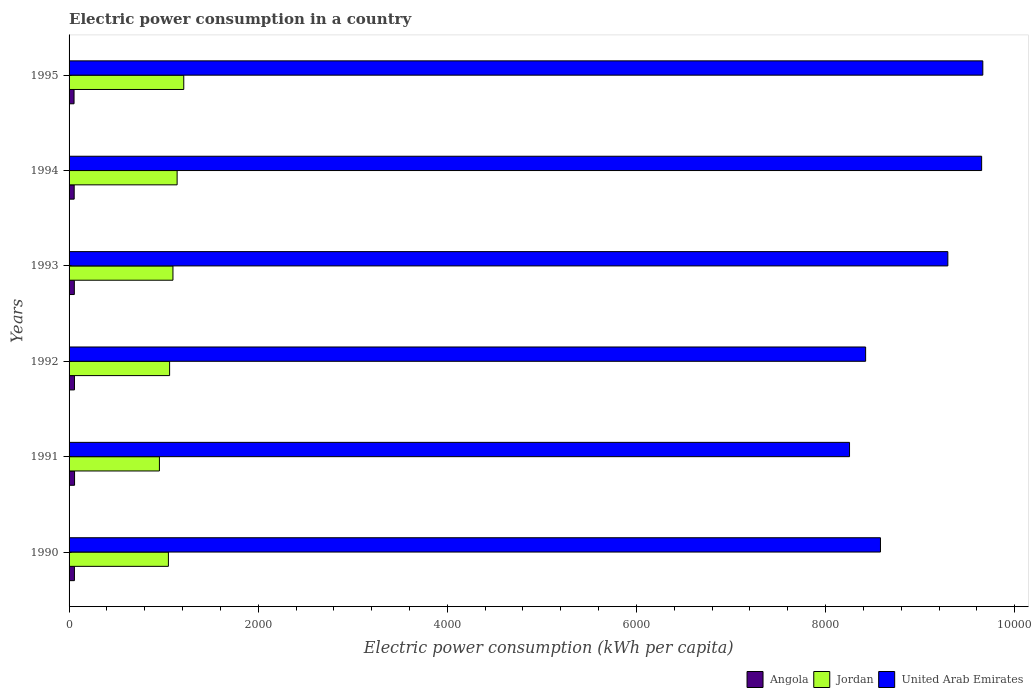How many groups of bars are there?
Provide a short and direct response. 6. Are the number of bars per tick equal to the number of legend labels?
Ensure brevity in your answer.  Yes. What is the label of the 3rd group of bars from the top?
Your answer should be compact. 1993. What is the electric power consumption in in Jordan in 1990?
Keep it short and to the point. 1050.47. Across all years, what is the maximum electric power consumption in in Angola?
Ensure brevity in your answer.  58.14. Across all years, what is the minimum electric power consumption in in Angola?
Your response must be concise. 52.67. In which year was the electric power consumption in in United Arab Emirates minimum?
Your response must be concise. 1991. What is the total electric power consumption in in Angola in the graph?
Offer a terse response. 334.17. What is the difference between the electric power consumption in in Angola in 1993 and that in 1995?
Your answer should be compact. 2.85. What is the difference between the electric power consumption in in United Arab Emirates in 1993 and the electric power consumption in in Jordan in 1991?
Provide a succinct answer. 8337.46. What is the average electric power consumption in in United Arab Emirates per year?
Your answer should be compact. 8977.13. In the year 1990, what is the difference between the electric power consumption in in United Arab Emirates and electric power consumption in in Angola?
Keep it short and to the point. 8523.77. What is the ratio of the electric power consumption in in United Arab Emirates in 1993 to that in 1995?
Give a very brief answer. 0.96. Is the electric power consumption in in Angola in 1993 less than that in 1995?
Ensure brevity in your answer.  No. Is the difference between the electric power consumption in in United Arab Emirates in 1991 and 1993 greater than the difference between the electric power consumption in in Angola in 1991 and 1993?
Make the answer very short. No. What is the difference between the highest and the second highest electric power consumption in in Angola?
Offer a very short reply. 1. What is the difference between the highest and the lowest electric power consumption in in Jordan?
Offer a very short reply. 257.44. In how many years, is the electric power consumption in in United Arab Emirates greater than the average electric power consumption in in United Arab Emirates taken over all years?
Give a very brief answer. 3. Is the sum of the electric power consumption in in Angola in 1991 and 1992 greater than the maximum electric power consumption in in Jordan across all years?
Your response must be concise. No. What does the 1st bar from the top in 1993 represents?
Ensure brevity in your answer.  United Arab Emirates. What does the 1st bar from the bottom in 1992 represents?
Ensure brevity in your answer.  Angola. What is the difference between two consecutive major ticks on the X-axis?
Your answer should be compact. 2000. Does the graph contain any zero values?
Give a very brief answer. No. Does the graph contain grids?
Your answer should be very brief. No. How many legend labels are there?
Give a very brief answer. 3. What is the title of the graph?
Provide a short and direct response. Electric power consumption in a country. Does "France" appear as one of the legend labels in the graph?
Give a very brief answer. No. What is the label or title of the X-axis?
Provide a succinct answer. Electric power consumption (kWh per capita). What is the Electric power consumption (kWh per capita) in Angola in 1990?
Your response must be concise. 56.61. What is the Electric power consumption (kWh per capita) in Jordan in 1990?
Offer a terse response. 1050.47. What is the Electric power consumption (kWh per capita) in United Arab Emirates in 1990?
Your answer should be compact. 8580.38. What is the Electric power consumption (kWh per capita) of Angola in 1991?
Keep it short and to the point. 58.14. What is the Electric power consumption (kWh per capita) in Jordan in 1991?
Your response must be concise. 955.43. What is the Electric power consumption (kWh per capita) in United Arab Emirates in 1991?
Make the answer very short. 8253.23. What is the Electric power consumption (kWh per capita) in Angola in 1992?
Provide a short and direct response. 57.14. What is the Electric power consumption (kWh per capita) of Jordan in 1992?
Provide a short and direct response. 1063.22. What is the Electric power consumption (kWh per capita) of United Arab Emirates in 1992?
Ensure brevity in your answer.  8423.42. What is the Electric power consumption (kWh per capita) in Angola in 1993?
Make the answer very short. 55.52. What is the Electric power consumption (kWh per capita) of Jordan in 1993?
Your response must be concise. 1098.57. What is the Electric power consumption (kWh per capita) in United Arab Emirates in 1993?
Keep it short and to the point. 9292.89. What is the Electric power consumption (kWh per capita) of Angola in 1994?
Your answer should be very brief. 54.08. What is the Electric power consumption (kWh per capita) of Jordan in 1994?
Your answer should be very brief. 1142.58. What is the Electric power consumption (kWh per capita) of United Arab Emirates in 1994?
Provide a short and direct response. 9650.26. What is the Electric power consumption (kWh per capita) of Angola in 1995?
Your answer should be very brief. 52.67. What is the Electric power consumption (kWh per capita) of Jordan in 1995?
Provide a short and direct response. 1212.87. What is the Electric power consumption (kWh per capita) in United Arab Emirates in 1995?
Keep it short and to the point. 9662.61. Across all years, what is the maximum Electric power consumption (kWh per capita) in Angola?
Your answer should be compact. 58.14. Across all years, what is the maximum Electric power consumption (kWh per capita) of Jordan?
Offer a terse response. 1212.87. Across all years, what is the maximum Electric power consumption (kWh per capita) of United Arab Emirates?
Make the answer very short. 9662.61. Across all years, what is the minimum Electric power consumption (kWh per capita) in Angola?
Provide a short and direct response. 52.67. Across all years, what is the minimum Electric power consumption (kWh per capita) in Jordan?
Provide a succinct answer. 955.43. Across all years, what is the minimum Electric power consumption (kWh per capita) in United Arab Emirates?
Make the answer very short. 8253.23. What is the total Electric power consumption (kWh per capita) of Angola in the graph?
Give a very brief answer. 334.17. What is the total Electric power consumption (kWh per capita) in Jordan in the graph?
Your response must be concise. 6523.14. What is the total Electric power consumption (kWh per capita) in United Arab Emirates in the graph?
Ensure brevity in your answer.  5.39e+04. What is the difference between the Electric power consumption (kWh per capita) in Angola in 1990 and that in 1991?
Keep it short and to the point. -1.53. What is the difference between the Electric power consumption (kWh per capita) of Jordan in 1990 and that in 1991?
Provide a short and direct response. 95.04. What is the difference between the Electric power consumption (kWh per capita) of United Arab Emirates in 1990 and that in 1991?
Offer a terse response. 327.15. What is the difference between the Electric power consumption (kWh per capita) in Angola in 1990 and that in 1992?
Your answer should be compact. -0.52. What is the difference between the Electric power consumption (kWh per capita) of Jordan in 1990 and that in 1992?
Provide a succinct answer. -12.75. What is the difference between the Electric power consumption (kWh per capita) in United Arab Emirates in 1990 and that in 1992?
Offer a terse response. 156.96. What is the difference between the Electric power consumption (kWh per capita) in Angola in 1990 and that in 1993?
Provide a short and direct response. 1.09. What is the difference between the Electric power consumption (kWh per capita) in Jordan in 1990 and that in 1993?
Provide a succinct answer. -48.09. What is the difference between the Electric power consumption (kWh per capita) of United Arab Emirates in 1990 and that in 1993?
Offer a very short reply. -712.51. What is the difference between the Electric power consumption (kWh per capita) of Angola in 1990 and that in 1994?
Provide a succinct answer. 2.54. What is the difference between the Electric power consumption (kWh per capita) of Jordan in 1990 and that in 1994?
Your answer should be very brief. -92.1. What is the difference between the Electric power consumption (kWh per capita) of United Arab Emirates in 1990 and that in 1994?
Your answer should be very brief. -1069.88. What is the difference between the Electric power consumption (kWh per capita) of Angola in 1990 and that in 1995?
Provide a short and direct response. 3.94. What is the difference between the Electric power consumption (kWh per capita) of Jordan in 1990 and that in 1995?
Ensure brevity in your answer.  -162.4. What is the difference between the Electric power consumption (kWh per capita) in United Arab Emirates in 1990 and that in 1995?
Your answer should be compact. -1082.23. What is the difference between the Electric power consumption (kWh per capita) in Angola in 1991 and that in 1992?
Make the answer very short. 1. What is the difference between the Electric power consumption (kWh per capita) of Jordan in 1991 and that in 1992?
Your answer should be very brief. -107.79. What is the difference between the Electric power consumption (kWh per capita) in United Arab Emirates in 1991 and that in 1992?
Your response must be concise. -170.19. What is the difference between the Electric power consumption (kWh per capita) in Angola in 1991 and that in 1993?
Provide a succinct answer. 2.62. What is the difference between the Electric power consumption (kWh per capita) in Jordan in 1991 and that in 1993?
Provide a short and direct response. -143.14. What is the difference between the Electric power consumption (kWh per capita) in United Arab Emirates in 1991 and that in 1993?
Your answer should be compact. -1039.66. What is the difference between the Electric power consumption (kWh per capita) in Angola in 1991 and that in 1994?
Provide a succinct answer. 4.06. What is the difference between the Electric power consumption (kWh per capita) in Jordan in 1991 and that in 1994?
Make the answer very short. -187.15. What is the difference between the Electric power consumption (kWh per capita) in United Arab Emirates in 1991 and that in 1994?
Make the answer very short. -1397.03. What is the difference between the Electric power consumption (kWh per capita) of Angola in 1991 and that in 1995?
Your answer should be very brief. 5.47. What is the difference between the Electric power consumption (kWh per capita) in Jordan in 1991 and that in 1995?
Offer a very short reply. -257.44. What is the difference between the Electric power consumption (kWh per capita) of United Arab Emirates in 1991 and that in 1995?
Offer a very short reply. -1409.38. What is the difference between the Electric power consumption (kWh per capita) of Angola in 1992 and that in 1993?
Offer a very short reply. 1.61. What is the difference between the Electric power consumption (kWh per capita) of Jordan in 1992 and that in 1993?
Your answer should be compact. -35.35. What is the difference between the Electric power consumption (kWh per capita) of United Arab Emirates in 1992 and that in 1993?
Your answer should be compact. -869.47. What is the difference between the Electric power consumption (kWh per capita) of Angola in 1992 and that in 1994?
Your answer should be very brief. 3.06. What is the difference between the Electric power consumption (kWh per capita) in Jordan in 1992 and that in 1994?
Offer a very short reply. -79.36. What is the difference between the Electric power consumption (kWh per capita) of United Arab Emirates in 1992 and that in 1994?
Offer a terse response. -1226.84. What is the difference between the Electric power consumption (kWh per capita) of Angola in 1992 and that in 1995?
Offer a terse response. 4.46. What is the difference between the Electric power consumption (kWh per capita) in Jordan in 1992 and that in 1995?
Offer a very short reply. -149.65. What is the difference between the Electric power consumption (kWh per capita) of United Arab Emirates in 1992 and that in 1995?
Your response must be concise. -1239.2. What is the difference between the Electric power consumption (kWh per capita) in Angola in 1993 and that in 1994?
Your answer should be very brief. 1.45. What is the difference between the Electric power consumption (kWh per capita) of Jordan in 1993 and that in 1994?
Make the answer very short. -44.01. What is the difference between the Electric power consumption (kWh per capita) in United Arab Emirates in 1993 and that in 1994?
Provide a succinct answer. -357.37. What is the difference between the Electric power consumption (kWh per capita) in Angola in 1993 and that in 1995?
Your response must be concise. 2.85. What is the difference between the Electric power consumption (kWh per capita) of Jordan in 1993 and that in 1995?
Your answer should be very brief. -114.31. What is the difference between the Electric power consumption (kWh per capita) in United Arab Emirates in 1993 and that in 1995?
Give a very brief answer. -369.72. What is the difference between the Electric power consumption (kWh per capita) of Angola in 1994 and that in 1995?
Keep it short and to the point. 1.4. What is the difference between the Electric power consumption (kWh per capita) in Jordan in 1994 and that in 1995?
Keep it short and to the point. -70.3. What is the difference between the Electric power consumption (kWh per capita) in United Arab Emirates in 1994 and that in 1995?
Provide a short and direct response. -12.35. What is the difference between the Electric power consumption (kWh per capita) in Angola in 1990 and the Electric power consumption (kWh per capita) in Jordan in 1991?
Provide a succinct answer. -898.82. What is the difference between the Electric power consumption (kWh per capita) in Angola in 1990 and the Electric power consumption (kWh per capita) in United Arab Emirates in 1991?
Provide a short and direct response. -8196.62. What is the difference between the Electric power consumption (kWh per capita) in Jordan in 1990 and the Electric power consumption (kWh per capita) in United Arab Emirates in 1991?
Your answer should be compact. -7202.76. What is the difference between the Electric power consumption (kWh per capita) in Angola in 1990 and the Electric power consumption (kWh per capita) in Jordan in 1992?
Provide a succinct answer. -1006.61. What is the difference between the Electric power consumption (kWh per capita) of Angola in 1990 and the Electric power consumption (kWh per capita) of United Arab Emirates in 1992?
Offer a terse response. -8366.8. What is the difference between the Electric power consumption (kWh per capita) in Jordan in 1990 and the Electric power consumption (kWh per capita) in United Arab Emirates in 1992?
Keep it short and to the point. -7372.95. What is the difference between the Electric power consumption (kWh per capita) of Angola in 1990 and the Electric power consumption (kWh per capita) of Jordan in 1993?
Your answer should be compact. -1041.95. What is the difference between the Electric power consumption (kWh per capita) of Angola in 1990 and the Electric power consumption (kWh per capita) of United Arab Emirates in 1993?
Make the answer very short. -9236.28. What is the difference between the Electric power consumption (kWh per capita) of Jordan in 1990 and the Electric power consumption (kWh per capita) of United Arab Emirates in 1993?
Keep it short and to the point. -8242.42. What is the difference between the Electric power consumption (kWh per capita) of Angola in 1990 and the Electric power consumption (kWh per capita) of Jordan in 1994?
Offer a very short reply. -1085.96. What is the difference between the Electric power consumption (kWh per capita) of Angola in 1990 and the Electric power consumption (kWh per capita) of United Arab Emirates in 1994?
Your answer should be very brief. -9593.65. What is the difference between the Electric power consumption (kWh per capita) in Jordan in 1990 and the Electric power consumption (kWh per capita) in United Arab Emirates in 1994?
Ensure brevity in your answer.  -8599.79. What is the difference between the Electric power consumption (kWh per capita) of Angola in 1990 and the Electric power consumption (kWh per capita) of Jordan in 1995?
Offer a very short reply. -1156.26. What is the difference between the Electric power consumption (kWh per capita) in Angola in 1990 and the Electric power consumption (kWh per capita) in United Arab Emirates in 1995?
Give a very brief answer. -9606. What is the difference between the Electric power consumption (kWh per capita) of Jordan in 1990 and the Electric power consumption (kWh per capita) of United Arab Emirates in 1995?
Provide a short and direct response. -8612.14. What is the difference between the Electric power consumption (kWh per capita) of Angola in 1991 and the Electric power consumption (kWh per capita) of Jordan in 1992?
Provide a short and direct response. -1005.08. What is the difference between the Electric power consumption (kWh per capita) in Angola in 1991 and the Electric power consumption (kWh per capita) in United Arab Emirates in 1992?
Offer a very short reply. -8365.28. What is the difference between the Electric power consumption (kWh per capita) of Jordan in 1991 and the Electric power consumption (kWh per capita) of United Arab Emirates in 1992?
Provide a short and direct response. -7467.99. What is the difference between the Electric power consumption (kWh per capita) of Angola in 1991 and the Electric power consumption (kWh per capita) of Jordan in 1993?
Your response must be concise. -1040.43. What is the difference between the Electric power consumption (kWh per capita) of Angola in 1991 and the Electric power consumption (kWh per capita) of United Arab Emirates in 1993?
Keep it short and to the point. -9234.75. What is the difference between the Electric power consumption (kWh per capita) of Jordan in 1991 and the Electric power consumption (kWh per capita) of United Arab Emirates in 1993?
Keep it short and to the point. -8337.46. What is the difference between the Electric power consumption (kWh per capita) of Angola in 1991 and the Electric power consumption (kWh per capita) of Jordan in 1994?
Make the answer very short. -1084.43. What is the difference between the Electric power consumption (kWh per capita) in Angola in 1991 and the Electric power consumption (kWh per capita) in United Arab Emirates in 1994?
Your answer should be compact. -9592.12. What is the difference between the Electric power consumption (kWh per capita) of Jordan in 1991 and the Electric power consumption (kWh per capita) of United Arab Emirates in 1994?
Ensure brevity in your answer.  -8694.83. What is the difference between the Electric power consumption (kWh per capita) in Angola in 1991 and the Electric power consumption (kWh per capita) in Jordan in 1995?
Make the answer very short. -1154.73. What is the difference between the Electric power consumption (kWh per capita) of Angola in 1991 and the Electric power consumption (kWh per capita) of United Arab Emirates in 1995?
Your answer should be compact. -9604.47. What is the difference between the Electric power consumption (kWh per capita) of Jordan in 1991 and the Electric power consumption (kWh per capita) of United Arab Emirates in 1995?
Your response must be concise. -8707.18. What is the difference between the Electric power consumption (kWh per capita) of Angola in 1992 and the Electric power consumption (kWh per capita) of Jordan in 1993?
Your answer should be compact. -1041.43. What is the difference between the Electric power consumption (kWh per capita) in Angola in 1992 and the Electric power consumption (kWh per capita) in United Arab Emirates in 1993?
Provide a short and direct response. -9235.76. What is the difference between the Electric power consumption (kWh per capita) of Jordan in 1992 and the Electric power consumption (kWh per capita) of United Arab Emirates in 1993?
Ensure brevity in your answer.  -8229.67. What is the difference between the Electric power consumption (kWh per capita) of Angola in 1992 and the Electric power consumption (kWh per capita) of Jordan in 1994?
Offer a terse response. -1085.44. What is the difference between the Electric power consumption (kWh per capita) in Angola in 1992 and the Electric power consumption (kWh per capita) in United Arab Emirates in 1994?
Provide a succinct answer. -9593.13. What is the difference between the Electric power consumption (kWh per capita) of Jordan in 1992 and the Electric power consumption (kWh per capita) of United Arab Emirates in 1994?
Keep it short and to the point. -8587.04. What is the difference between the Electric power consumption (kWh per capita) in Angola in 1992 and the Electric power consumption (kWh per capita) in Jordan in 1995?
Your response must be concise. -1155.74. What is the difference between the Electric power consumption (kWh per capita) of Angola in 1992 and the Electric power consumption (kWh per capita) of United Arab Emirates in 1995?
Ensure brevity in your answer.  -9605.48. What is the difference between the Electric power consumption (kWh per capita) in Jordan in 1992 and the Electric power consumption (kWh per capita) in United Arab Emirates in 1995?
Provide a succinct answer. -8599.39. What is the difference between the Electric power consumption (kWh per capita) of Angola in 1993 and the Electric power consumption (kWh per capita) of Jordan in 1994?
Give a very brief answer. -1087.05. What is the difference between the Electric power consumption (kWh per capita) in Angola in 1993 and the Electric power consumption (kWh per capita) in United Arab Emirates in 1994?
Offer a very short reply. -9594.74. What is the difference between the Electric power consumption (kWh per capita) in Jordan in 1993 and the Electric power consumption (kWh per capita) in United Arab Emirates in 1994?
Offer a very short reply. -8551.7. What is the difference between the Electric power consumption (kWh per capita) of Angola in 1993 and the Electric power consumption (kWh per capita) of Jordan in 1995?
Offer a very short reply. -1157.35. What is the difference between the Electric power consumption (kWh per capita) of Angola in 1993 and the Electric power consumption (kWh per capita) of United Arab Emirates in 1995?
Keep it short and to the point. -9607.09. What is the difference between the Electric power consumption (kWh per capita) in Jordan in 1993 and the Electric power consumption (kWh per capita) in United Arab Emirates in 1995?
Keep it short and to the point. -8564.05. What is the difference between the Electric power consumption (kWh per capita) in Angola in 1994 and the Electric power consumption (kWh per capita) in Jordan in 1995?
Give a very brief answer. -1158.79. What is the difference between the Electric power consumption (kWh per capita) in Angola in 1994 and the Electric power consumption (kWh per capita) in United Arab Emirates in 1995?
Provide a succinct answer. -9608.54. What is the difference between the Electric power consumption (kWh per capita) in Jordan in 1994 and the Electric power consumption (kWh per capita) in United Arab Emirates in 1995?
Your response must be concise. -8520.04. What is the average Electric power consumption (kWh per capita) of Angola per year?
Your response must be concise. 55.69. What is the average Electric power consumption (kWh per capita) in Jordan per year?
Give a very brief answer. 1087.19. What is the average Electric power consumption (kWh per capita) in United Arab Emirates per year?
Ensure brevity in your answer.  8977.13. In the year 1990, what is the difference between the Electric power consumption (kWh per capita) of Angola and Electric power consumption (kWh per capita) of Jordan?
Your response must be concise. -993.86. In the year 1990, what is the difference between the Electric power consumption (kWh per capita) of Angola and Electric power consumption (kWh per capita) of United Arab Emirates?
Offer a very short reply. -8523.77. In the year 1990, what is the difference between the Electric power consumption (kWh per capita) in Jordan and Electric power consumption (kWh per capita) in United Arab Emirates?
Your answer should be very brief. -7529.91. In the year 1991, what is the difference between the Electric power consumption (kWh per capita) of Angola and Electric power consumption (kWh per capita) of Jordan?
Give a very brief answer. -897.29. In the year 1991, what is the difference between the Electric power consumption (kWh per capita) in Angola and Electric power consumption (kWh per capita) in United Arab Emirates?
Ensure brevity in your answer.  -8195.09. In the year 1991, what is the difference between the Electric power consumption (kWh per capita) in Jordan and Electric power consumption (kWh per capita) in United Arab Emirates?
Make the answer very short. -7297.8. In the year 1992, what is the difference between the Electric power consumption (kWh per capita) in Angola and Electric power consumption (kWh per capita) in Jordan?
Offer a terse response. -1006.08. In the year 1992, what is the difference between the Electric power consumption (kWh per capita) of Angola and Electric power consumption (kWh per capita) of United Arab Emirates?
Provide a succinct answer. -8366.28. In the year 1992, what is the difference between the Electric power consumption (kWh per capita) in Jordan and Electric power consumption (kWh per capita) in United Arab Emirates?
Make the answer very short. -7360.2. In the year 1993, what is the difference between the Electric power consumption (kWh per capita) in Angola and Electric power consumption (kWh per capita) in Jordan?
Offer a terse response. -1043.04. In the year 1993, what is the difference between the Electric power consumption (kWh per capita) of Angola and Electric power consumption (kWh per capita) of United Arab Emirates?
Offer a very short reply. -9237.37. In the year 1993, what is the difference between the Electric power consumption (kWh per capita) of Jordan and Electric power consumption (kWh per capita) of United Arab Emirates?
Provide a succinct answer. -8194.33. In the year 1994, what is the difference between the Electric power consumption (kWh per capita) in Angola and Electric power consumption (kWh per capita) in Jordan?
Ensure brevity in your answer.  -1088.5. In the year 1994, what is the difference between the Electric power consumption (kWh per capita) of Angola and Electric power consumption (kWh per capita) of United Arab Emirates?
Give a very brief answer. -9596.19. In the year 1994, what is the difference between the Electric power consumption (kWh per capita) in Jordan and Electric power consumption (kWh per capita) in United Arab Emirates?
Keep it short and to the point. -8507.69. In the year 1995, what is the difference between the Electric power consumption (kWh per capita) of Angola and Electric power consumption (kWh per capita) of Jordan?
Ensure brevity in your answer.  -1160.2. In the year 1995, what is the difference between the Electric power consumption (kWh per capita) in Angola and Electric power consumption (kWh per capita) in United Arab Emirates?
Provide a succinct answer. -9609.94. In the year 1995, what is the difference between the Electric power consumption (kWh per capita) of Jordan and Electric power consumption (kWh per capita) of United Arab Emirates?
Give a very brief answer. -8449.74. What is the ratio of the Electric power consumption (kWh per capita) in Angola in 1990 to that in 1991?
Your answer should be compact. 0.97. What is the ratio of the Electric power consumption (kWh per capita) of Jordan in 1990 to that in 1991?
Offer a terse response. 1.1. What is the ratio of the Electric power consumption (kWh per capita) of United Arab Emirates in 1990 to that in 1991?
Provide a short and direct response. 1.04. What is the ratio of the Electric power consumption (kWh per capita) in Angola in 1990 to that in 1992?
Give a very brief answer. 0.99. What is the ratio of the Electric power consumption (kWh per capita) in Jordan in 1990 to that in 1992?
Your answer should be compact. 0.99. What is the ratio of the Electric power consumption (kWh per capita) of United Arab Emirates in 1990 to that in 1992?
Make the answer very short. 1.02. What is the ratio of the Electric power consumption (kWh per capita) in Angola in 1990 to that in 1993?
Give a very brief answer. 1.02. What is the ratio of the Electric power consumption (kWh per capita) in Jordan in 1990 to that in 1993?
Make the answer very short. 0.96. What is the ratio of the Electric power consumption (kWh per capita) of United Arab Emirates in 1990 to that in 1993?
Give a very brief answer. 0.92. What is the ratio of the Electric power consumption (kWh per capita) in Angola in 1990 to that in 1994?
Make the answer very short. 1.05. What is the ratio of the Electric power consumption (kWh per capita) of Jordan in 1990 to that in 1994?
Keep it short and to the point. 0.92. What is the ratio of the Electric power consumption (kWh per capita) of United Arab Emirates in 1990 to that in 1994?
Offer a very short reply. 0.89. What is the ratio of the Electric power consumption (kWh per capita) in Angola in 1990 to that in 1995?
Offer a very short reply. 1.07. What is the ratio of the Electric power consumption (kWh per capita) in Jordan in 1990 to that in 1995?
Your response must be concise. 0.87. What is the ratio of the Electric power consumption (kWh per capita) of United Arab Emirates in 1990 to that in 1995?
Provide a short and direct response. 0.89. What is the ratio of the Electric power consumption (kWh per capita) in Angola in 1991 to that in 1992?
Provide a short and direct response. 1.02. What is the ratio of the Electric power consumption (kWh per capita) in Jordan in 1991 to that in 1992?
Offer a terse response. 0.9. What is the ratio of the Electric power consumption (kWh per capita) in United Arab Emirates in 1991 to that in 1992?
Your response must be concise. 0.98. What is the ratio of the Electric power consumption (kWh per capita) of Angola in 1991 to that in 1993?
Provide a succinct answer. 1.05. What is the ratio of the Electric power consumption (kWh per capita) in Jordan in 1991 to that in 1993?
Offer a very short reply. 0.87. What is the ratio of the Electric power consumption (kWh per capita) of United Arab Emirates in 1991 to that in 1993?
Your response must be concise. 0.89. What is the ratio of the Electric power consumption (kWh per capita) in Angola in 1991 to that in 1994?
Provide a short and direct response. 1.08. What is the ratio of the Electric power consumption (kWh per capita) of Jordan in 1991 to that in 1994?
Give a very brief answer. 0.84. What is the ratio of the Electric power consumption (kWh per capita) in United Arab Emirates in 1991 to that in 1994?
Your response must be concise. 0.86. What is the ratio of the Electric power consumption (kWh per capita) of Angola in 1991 to that in 1995?
Make the answer very short. 1.1. What is the ratio of the Electric power consumption (kWh per capita) of Jordan in 1991 to that in 1995?
Your answer should be very brief. 0.79. What is the ratio of the Electric power consumption (kWh per capita) of United Arab Emirates in 1991 to that in 1995?
Provide a short and direct response. 0.85. What is the ratio of the Electric power consumption (kWh per capita) in Angola in 1992 to that in 1993?
Make the answer very short. 1.03. What is the ratio of the Electric power consumption (kWh per capita) of Jordan in 1992 to that in 1993?
Your answer should be compact. 0.97. What is the ratio of the Electric power consumption (kWh per capita) in United Arab Emirates in 1992 to that in 1993?
Make the answer very short. 0.91. What is the ratio of the Electric power consumption (kWh per capita) in Angola in 1992 to that in 1994?
Provide a short and direct response. 1.06. What is the ratio of the Electric power consumption (kWh per capita) of Jordan in 1992 to that in 1994?
Your response must be concise. 0.93. What is the ratio of the Electric power consumption (kWh per capita) in United Arab Emirates in 1992 to that in 1994?
Make the answer very short. 0.87. What is the ratio of the Electric power consumption (kWh per capita) of Angola in 1992 to that in 1995?
Offer a terse response. 1.08. What is the ratio of the Electric power consumption (kWh per capita) in Jordan in 1992 to that in 1995?
Offer a very short reply. 0.88. What is the ratio of the Electric power consumption (kWh per capita) in United Arab Emirates in 1992 to that in 1995?
Provide a short and direct response. 0.87. What is the ratio of the Electric power consumption (kWh per capita) of Angola in 1993 to that in 1994?
Provide a succinct answer. 1.03. What is the ratio of the Electric power consumption (kWh per capita) in Jordan in 1993 to that in 1994?
Ensure brevity in your answer.  0.96. What is the ratio of the Electric power consumption (kWh per capita) in Angola in 1993 to that in 1995?
Your response must be concise. 1.05. What is the ratio of the Electric power consumption (kWh per capita) of Jordan in 1993 to that in 1995?
Make the answer very short. 0.91. What is the ratio of the Electric power consumption (kWh per capita) in United Arab Emirates in 1993 to that in 1995?
Give a very brief answer. 0.96. What is the ratio of the Electric power consumption (kWh per capita) of Angola in 1994 to that in 1995?
Keep it short and to the point. 1.03. What is the ratio of the Electric power consumption (kWh per capita) of Jordan in 1994 to that in 1995?
Offer a very short reply. 0.94. What is the difference between the highest and the second highest Electric power consumption (kWh per capita) of Jordan?
Your response must be concise. 70.3. What is the difference between the highest and the second highest Electric power consumption (kWh per capita) in United Arab Emirates?
Offer a terse response. 12.35. What is the difference between the highest and the lowest Electric power consumption (kWh per capita) of Angola?
Your answer should be compact. 5.47. What is the difference between the highest and the lowest Electric power consumption (kWh per capita) of Jordan?
Offer a terse response. 257.44. What is the difference between the highest and the lowest Electric power consumption (kWh per capita) in United Arab Emirates?
Provide a short and direct response. 1409.38. 